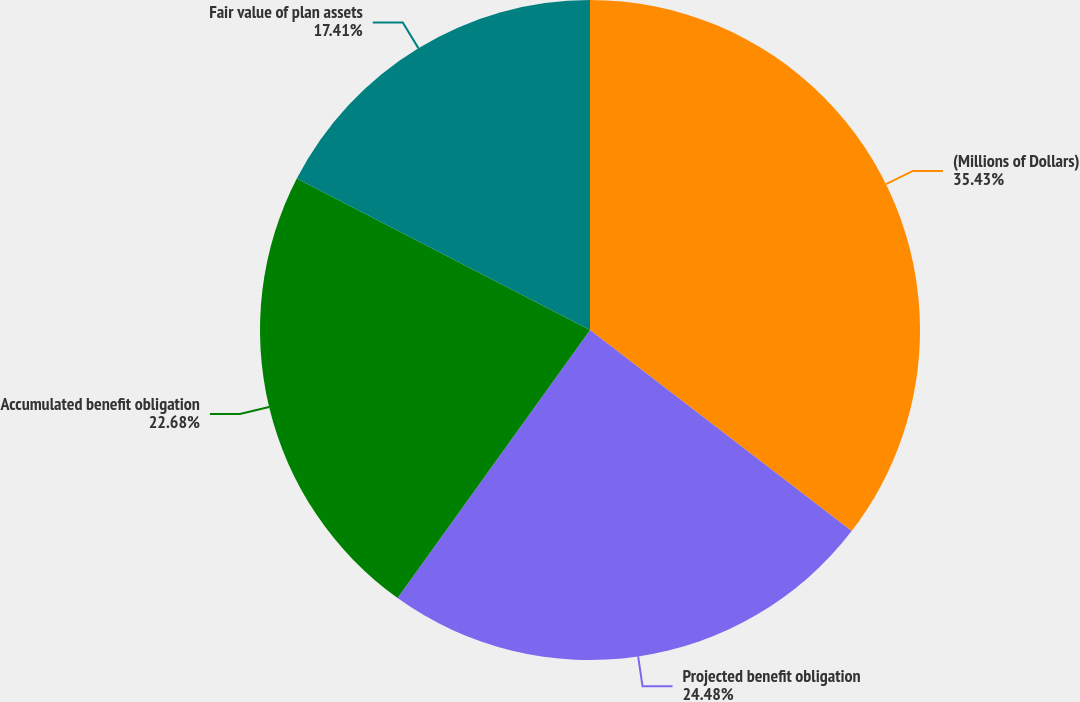<chart> <loc_0><loc_0><loc_500><loc_500><pie_chart><fcel>(Millions of Dollars)<fcel>Projected benefit obligation<fcel>Accumulated benefit obligation<fcel>Fair value of plan assets<nl><fcel>35.43%<fcel>24.48%<fcel>22.68%<fcel>17.41%<nl></chart> 